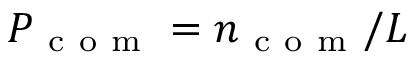<formula> <loc_0><loc_0><loc_500><loc_500>P _ { c o m } = n _ { c o m } / L</formula> 